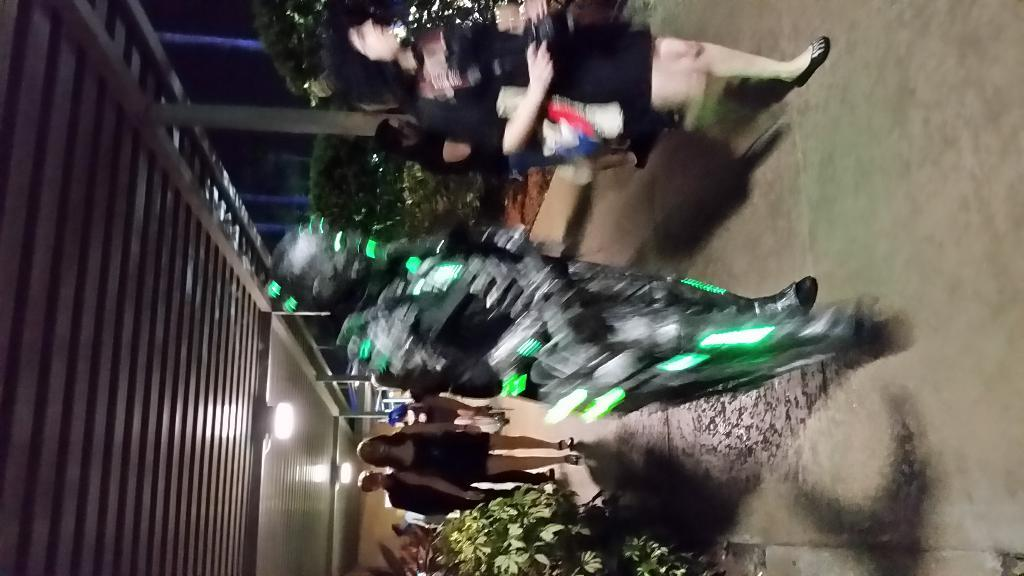How many people can be seen in the image? There are a few people in the image. What can be seen beneath the people's feet? The ground is visible in the image. What type of vegetation is present in the image? There are plants in the image. What structure is illuminated in the image? There is a shed with lights in the image. What are the tall, thin objects in the image? There are poles in the image. What type of chin is visible on the people in the image? There is no mention of a chin in the image; the focus is on the people, ground, plants, shed, and poles. 